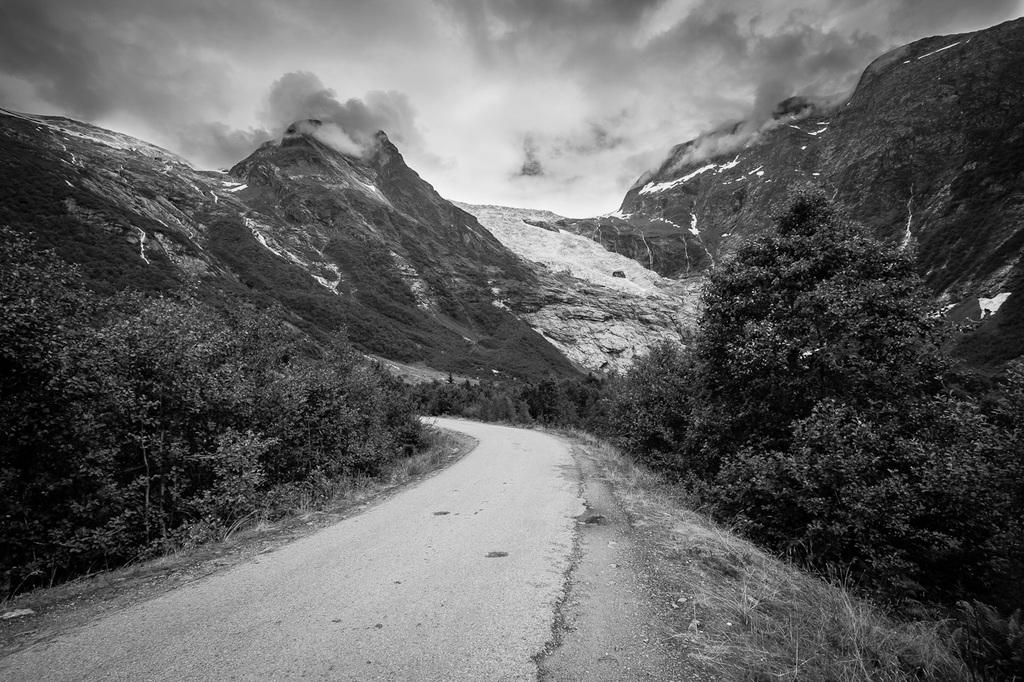What is the main feature of the image? There is a road in the image. What can be seen beside the road? Trees are visible beside the road. What is visible in the background of the image? There are mountains and the sky in the background of the image. What sense can be used to experience the rhythm of the road in the image? The image does not depict a rhythm or any sensory experience related to the road. 